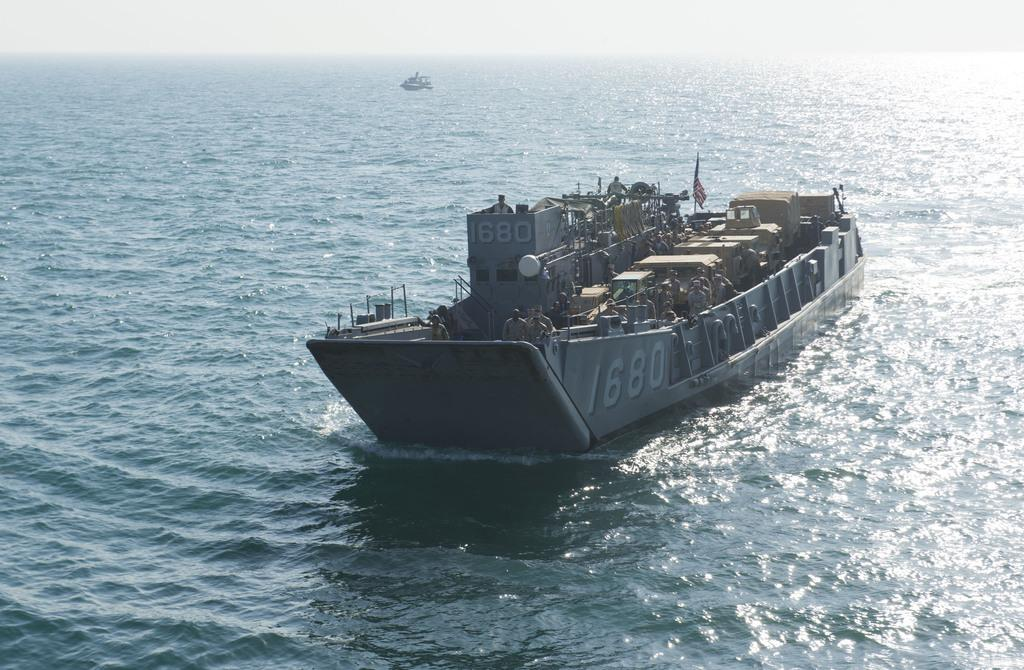What type of vehicles are in the image? There are boats in the image. Where are the boats located? The boats are on the water. What color is the chin of the person sitting on the sofa in the image? There is no person sitting on a sofa in the image; it features boats on the water. 